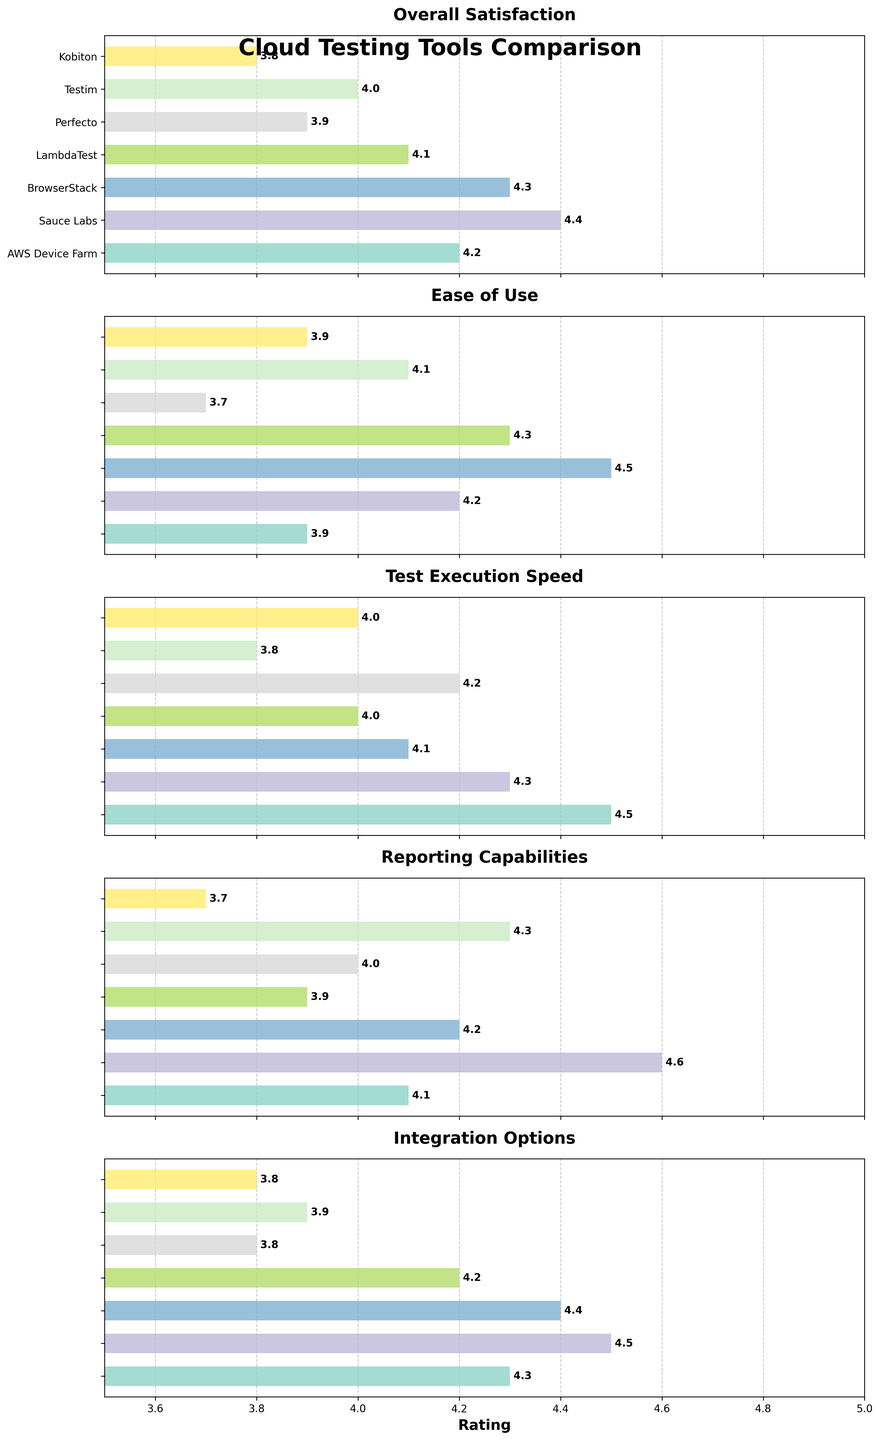What is the overall satisfaction rating for AWS Device Farm? The overall satisfaction rating for AWS Device Farm is directly shown in the bar graph for "Overall Satisfaction." Locate AWS Device Farm on the y-axis and find the corresponding value.
Answer: 4.2 Which tool has the highest rating in Ease of Use? Look at the bar graph for "Ease of Use" and find the bar with the highest value. Cross-reference it with the tool on the y-axis.
Answer: BrowserStack Which tool has the lowest rating in Test Execution Speed? Look at the bar graph for "Test Execution Speed" and identify the shortest bar. Cross-reference it with the tool on the y-axis.
Answer: Testim Compare the reporting capabilities of Perfecto and Sauce Labs. Which one is higher? Locate the bars for Perfecto and Sauce Labs in the "Reporting Capabilities" graph. Sauce Labs has a rating of 4.6 while Perfecto has a rating of 4.0.
Answer: Sauce Labs How does the integration options rating for BrowserStack compare to LambdaTest? Observe the "Integration Options" bar graph and compare the lengths of the bars for BrowserStack and LambdaTest. BrowserStack has a rating of 4.4 and LambdaTest has 4.2.
Answer: BrowserStack What's the average of the overall satisfaction ratings of all tools? Add up all the overall satisfaction ratings and divide by the number of tools. The values are 4.2, 4.4, 4.3, 4.1, 3.9, 4.0, 3.8. Sum = 28.7. Average = 28.7 / 7
Answer: 4.1 Which feature has the least variation in ratings across all tools? Compare the length and variation of bars for each feature. "Overall Satisfaction" has the least variation, with ratings ranging from 3.8 to 4.4.
Answer: Overall Satisfaction Which tool has the most consistent ratings across all features? Look for bars with the least variation in their lengths for a single tool across all features. Sauce Labs has consistently high ratings across the board.
Answer: Sauce Labs 